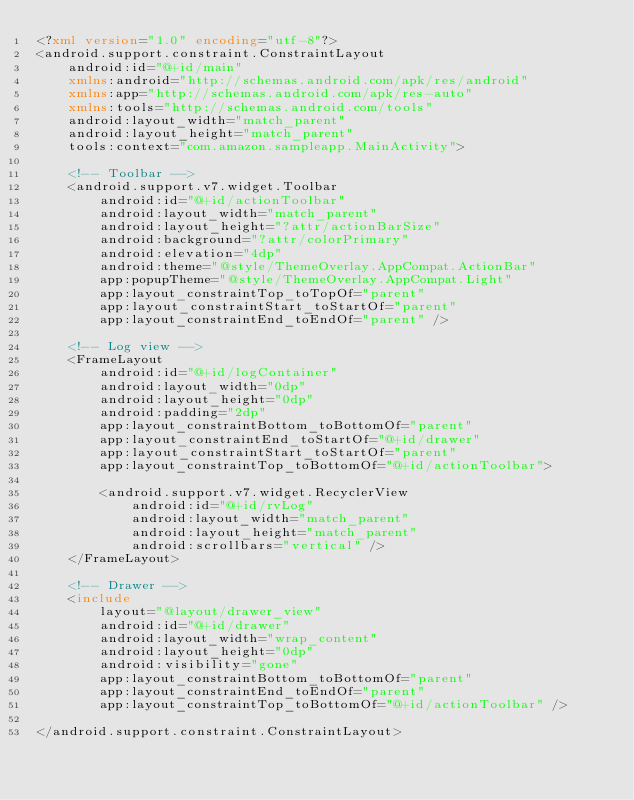Convert code to text. <code><loc_0><loc_0><loc_500><loc_500><_XML_><?xml version="1.0" encoding="utf-8"?>
<android.support.constraint.ConstraintLayout
    android:id="@+id/main"
    xmlns:android="http://schemas.android.com/apk/res/android"
    xmlns:app="http://schemas.android.com/apk/res-auto"
    xmlns:tools="http://schemas.android.com/tools"
    android:layout_width="match_parent"
    android:layout_height="match_parent"
    tools:context="com.amazon.sampleapp.MainActivity">

    <!-- Toolbar -->
    <android.support.v7.widget.Toolbar
        android:id="@+id/actionToolbar"
        android:layout_width="match_parent"
        android:layout_height="?attr/actionBarSize"
        android:background="?attr/colorPrimary"
        android:elevation="4dp"
        android:theme="@style/ThemeOverlay.AppCompat.ActionBar"
        app:popupTheme="@style/ThemeOverlay.AppCompat.Light"
        app:layout_constraintTop_toTopOf="parent"
        app:layout_constraintStart_toStartOf="parent"
        app:layout_constraintEnd_toEndOf="parent" />

    <!-- Log view -->
    <FrameLayout
        android:id="@+id/logContainer"
        android:layout_width="0dp"
        android:layout_height="0dp"
        android:padding="2dp"
        app:layout_constraintBottom_toBottomOf="parent"
        app:layout_constraintEnd_toStartOf="@+id/drawer"
        app:layout_constraintStart_toStartOf="parent"
        app:layout_constraintTop_toBottomOf="@+id/actionToolbar">

        <android.support.v7.widget.RecyclerView
            android:id="@+id/rvLog"
            android:layout_width="match_parent"
            android:layout_height="match_parent"
            android:scrollbars="vertical" />
    </FrameLayout>

    <!-- Drawer -->
    <include
        layout="@layout/drawer_view"
        android:id="@+id/drawer"
        android:layout_width="wrap_content"
        android:layout_height="0dp"
        android:visibility="gone"
        app:layout_constraintBottom_toBottomOf="parent"
        app:layout_constraintEnd_toEndOf="parent"
        app:layout_constraintTop_toBottomOf="@+id/actionToolbar" />

</android.support.constraint.ConstraintLayout></code> 